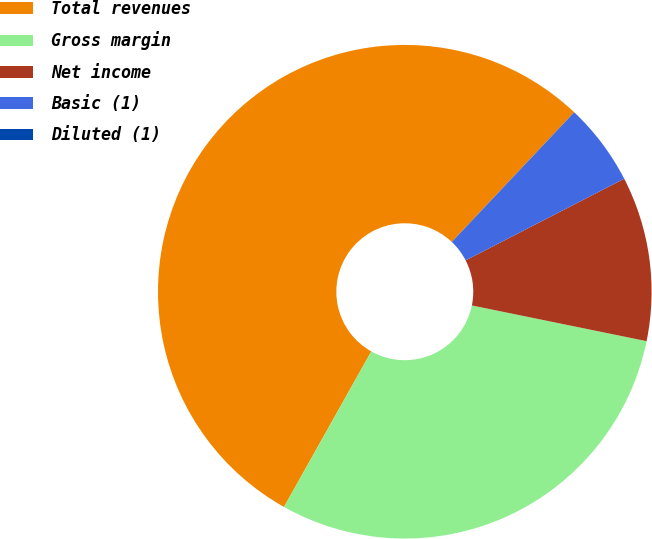Convert chart to OTSL. <chart><loc_0><loc_0><loc_500><loc_500><pie_chart><fcel>Total revenues<fcel>Gross margin<fcel>Net income<fcel>Basic (1)<fcel>Diluted (1)<nl><fcel>53.9%<fcel>29.93%<fcel>10.78%<fcel>5.39%<fcel>0.0%<nl></chart> 